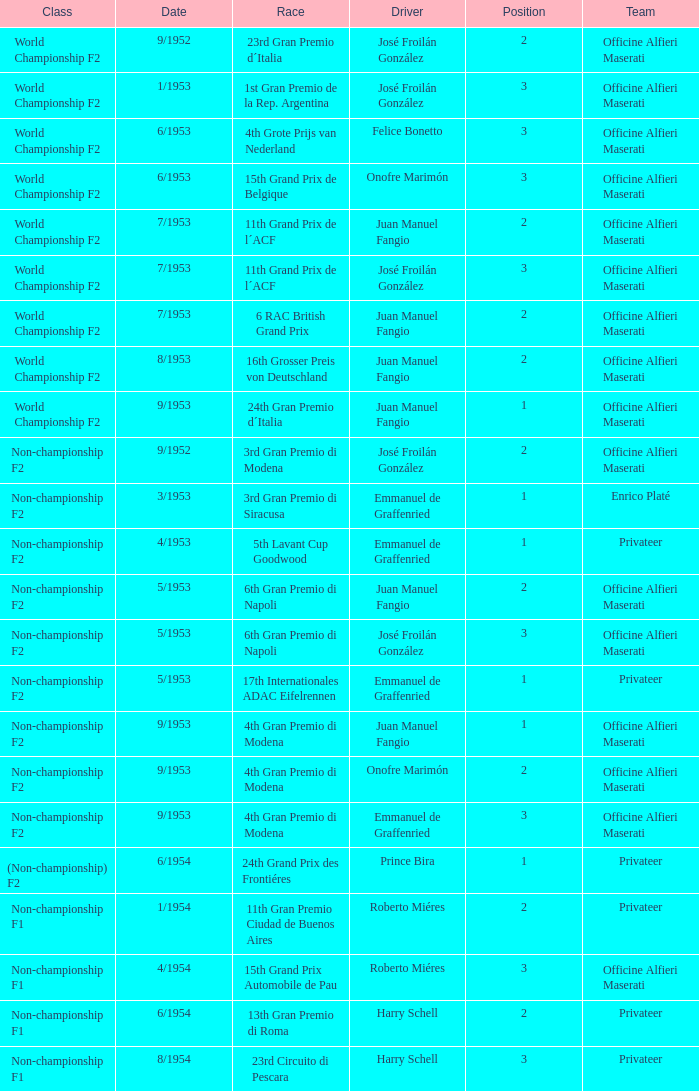What team has a drive name emmanuel de graffenried and a position larger than 1 as well as the date of 9/1953? Officine Alfieri Maserati. 